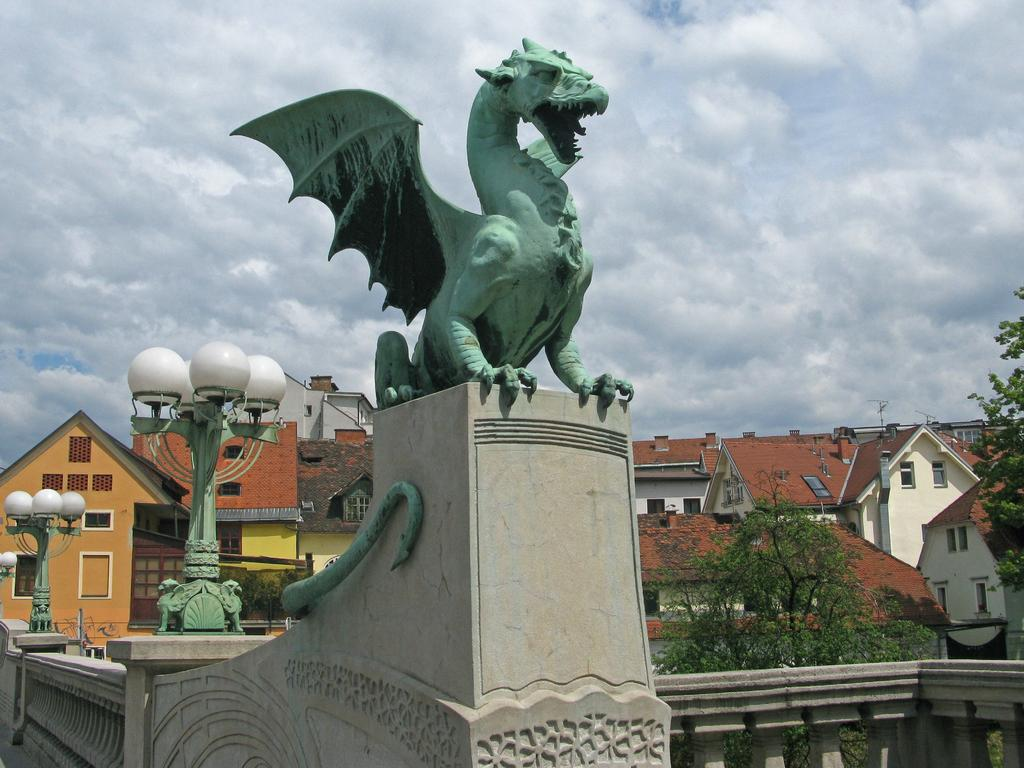What is the main subject in the center of the image? There is a statue in the center of the image. What type of barrier can be seen in the image? There is a fence in the image. What type of buildings are visible in the image? There are houses with roofs and windows in the image. What type of lighting is present in the image? There are street lamps in the image. What type of vegetation is visible in the image? There are trees in the image. What is the condition of the sky in the image? The sky is visible and appears cloudy in the image. Where is the lunchroom located in the image? There is no lunchroom present in the image. How does the wave affect the statue in the image? There is no wave present in the image, so it cannot affect the statue. 